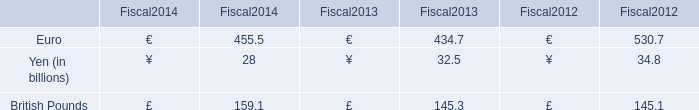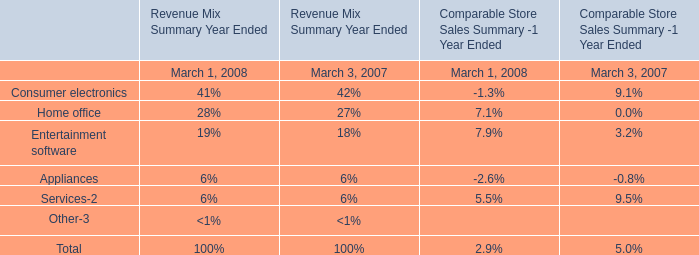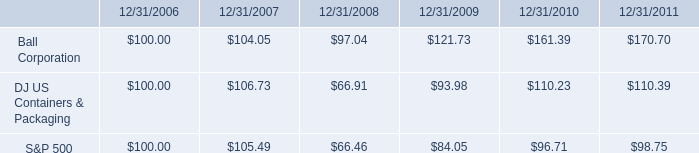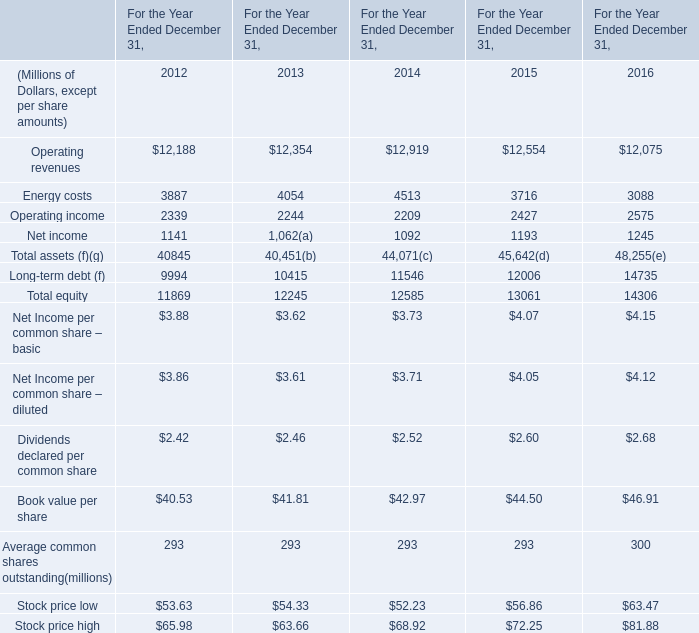What is the growing rate of Operating income in Table 3 in the year with the most British Pounds in Table 0? 
Computations: ((2209 - 2244) / 2244)
Answer: -0.0156. 